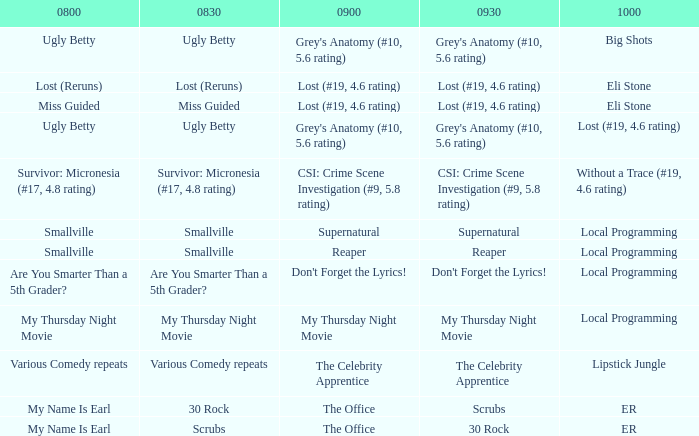What is at 10:00 when at 9:00 it is reaper? Local Programming. 